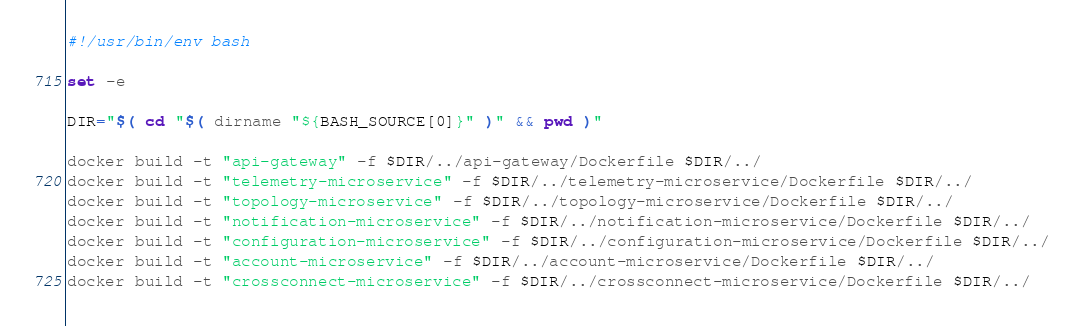Convert code to text. <code><loc_0><loc_0><loc_500><loc_500><_Bash_>#!/usr/bin/env bash

set -e

DIR="$( cd "$( dirname "${BASH_SOURCE[0]}" )" && pwd )"

docker build -t "api-gateway" -f $DIR/../api-gateway/Dockerfile $DIR/../
docker build -t "telemetry-microservice" -f $DIR/../telemetry-microservice/Dockerfile $DIR/../
docker build -t "topology-microservice" -f $DIR/../topology-microservice/Dockerfile $DIR/../
docker build -t "notification-microservice" -f $DIR/../notification-microservice/Dockerfile $DIR/../
docker build -t "configuration-microservice" -f $DIR/../configuration-microservice/Dockerfile $DIR/../
docker build -t "account-microservice" -f $DIR/../account-microservice/Dockerfile $DIR/../
docker build -t "crossconnect-microservice" -f $DIR/../crossconnect-microservice/Dockerfile $DIR/../</code> 